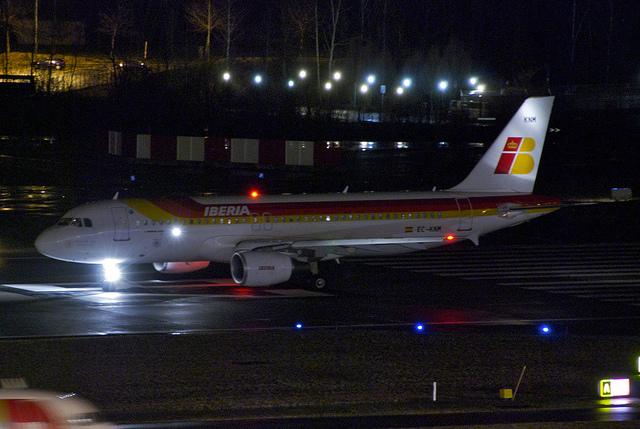How many engines are visible?
Be succinct. 2. What kind of transport is shown?
Answer briefly. Airplane. What airline is this?
Answer briefly. Iberia. 